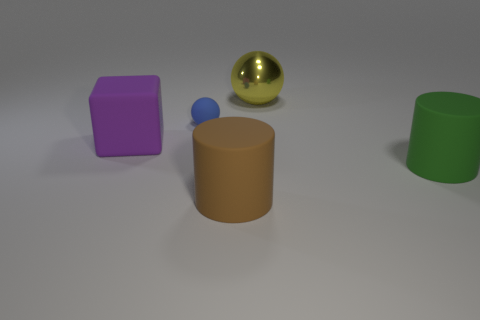How many other objects are the same size as the purple rubber block?
Make the answer very short. 3. Do the large thing that is to the left of the tiny blue matte thing and the big green cylinder have the same material?
Offer a terse response. Yes. What number of other objects are there of the same color as the large cube?
Offer a terse response. 0. What number of other things are there of the same shape as the brown thing?
Offer a very short reply. 1. There is a large object behind the small blue matte ball; is its shape the same as the matte object behind the large rubber block?
Give a very brief answer. Yes. Are there the same number of large green cylinders that are behind the blue sphere and rubber objects that are behind the large purple matte thing?
Offer a terse response. No. The big rubber object on the right side of the sphere right of the brown matte cylinder that is left of the yellow object is what shape?
Keep it short and to the point. Cylinder. Is the material of the object to the left of the tiny ball the same as the big cylinder to the right of the brown rubber thing?
Your answer should be compact. Yes. There is a matte object behind the large purple thing; what is its shape?
Make the answer very short. Sphere. Is the number of blue rubber objects less than the number of large gray shiny objects?
Ensure brevity in your answer.  No. 